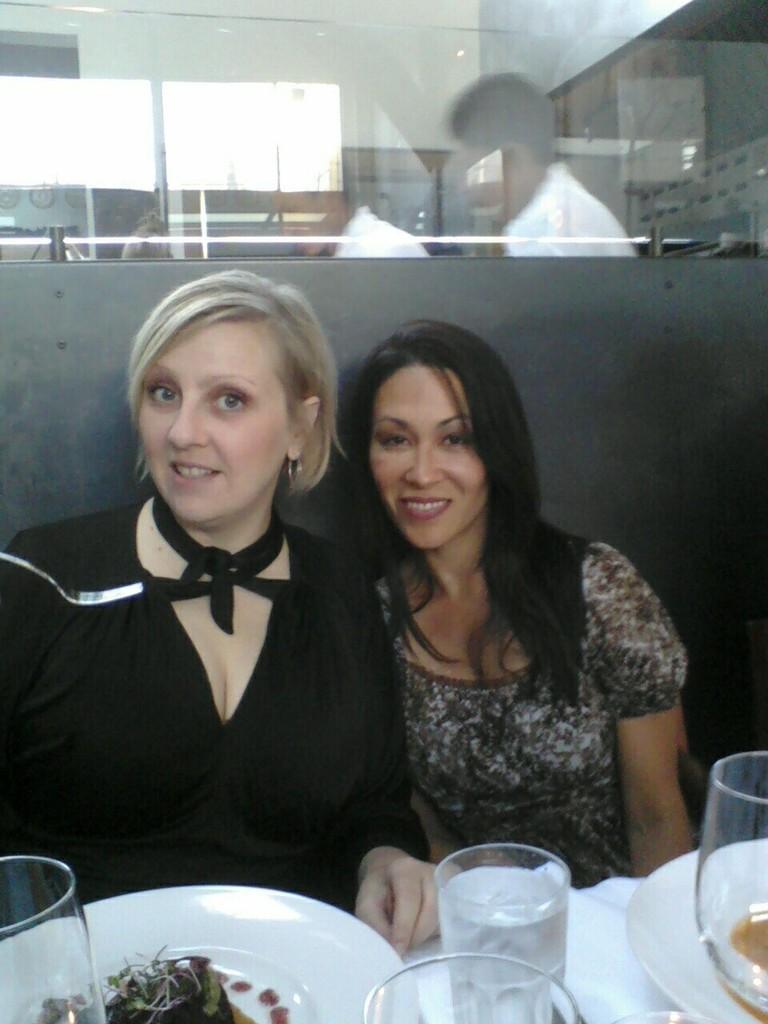How would you summarize this image in a sentence or two? In this image there are two women who are sitting, and at the bottom there are plates, glasses. And in the plates there is food and there is a cloth, and in the background there is a board and glass window and through the we could see a reflection of one person poles, wall, windows and some objects. 